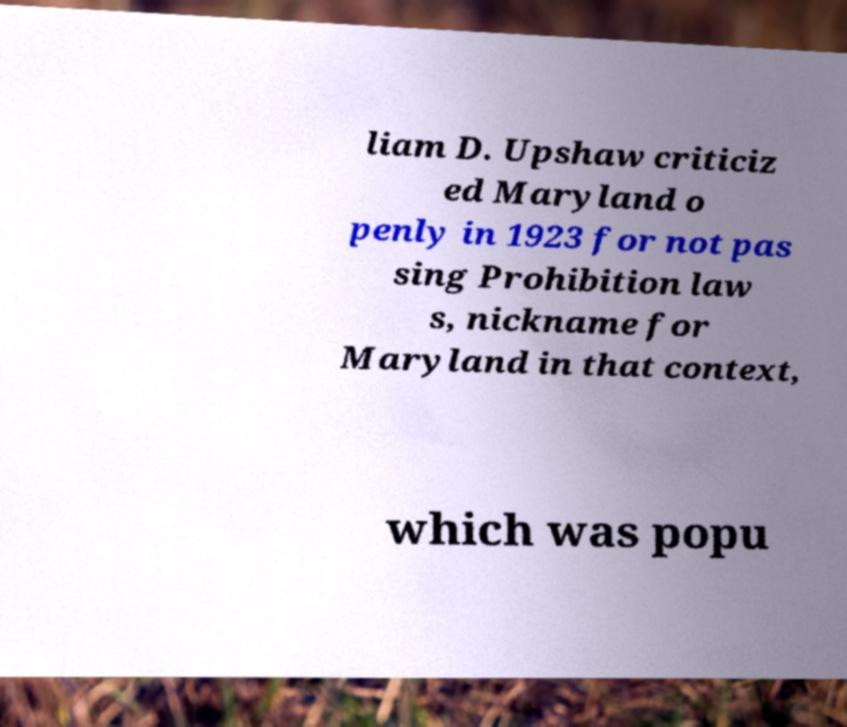Could you assist in decoding the text presented in this image and type it out clearly? liam D. Upshaw criticiz ed Maryland o penly in 1923 for not pas sing Prohibition law s, nickname for Maryland in that context, which was popu 